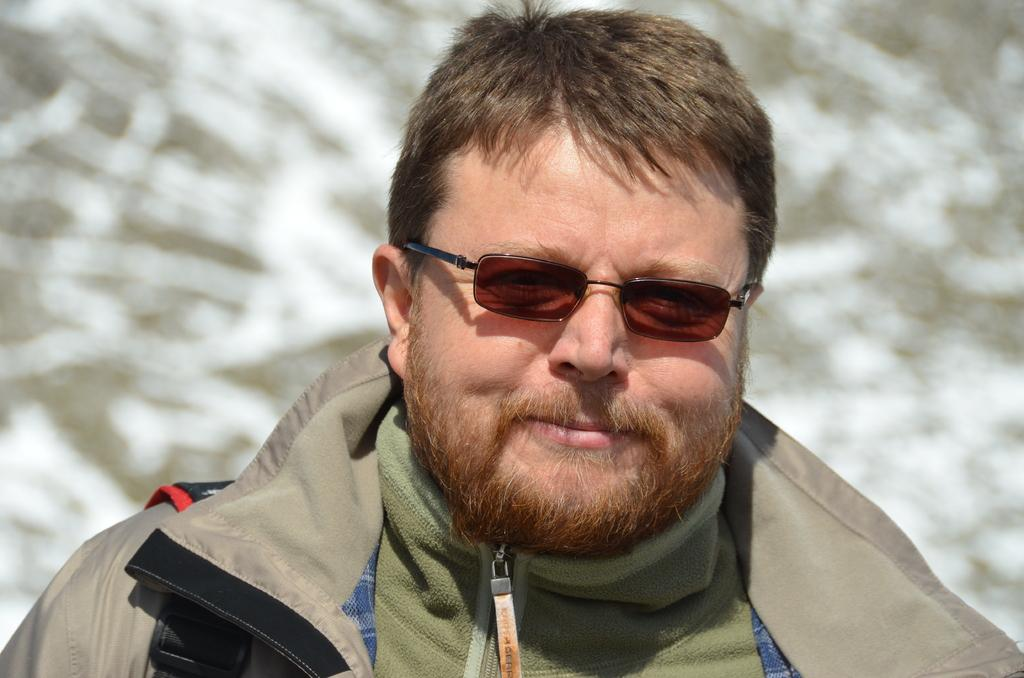Where was the image taken? The image was taken outdoors. Can you describe the background of the image? The background of the image is slightly blurred. Who is the main subject in the image? There is a man in the middle of the image. What is the man's facial expression? The man has a smiling face. What type of apparel is the secretary wearing in the image? There is no secretary present in the image, and therefore no apparel can be described. 